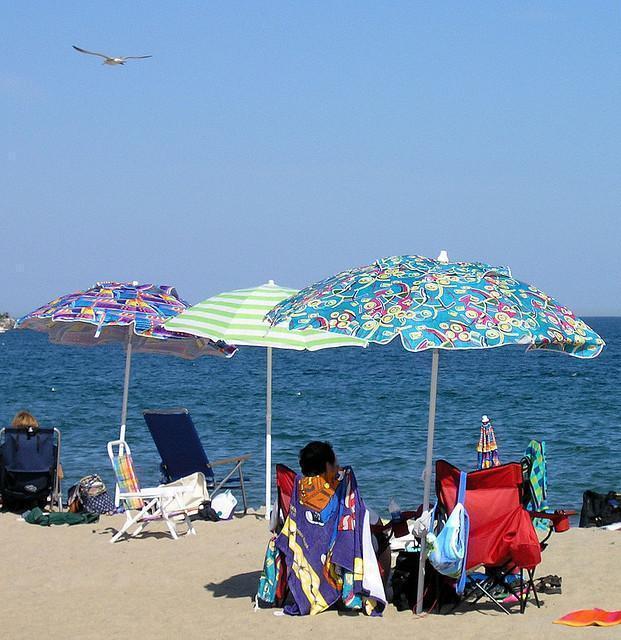What other situation might the standing items be useful for?
Pick the right solution, then justify: 'Answer: answer
Rationale: rationale.'
Options: Hurricane, snow, rain, wind. Answer: rain.
Rationale: The umbrellas on the beach are being used to shield the sun but it can also be used when it's raining. 